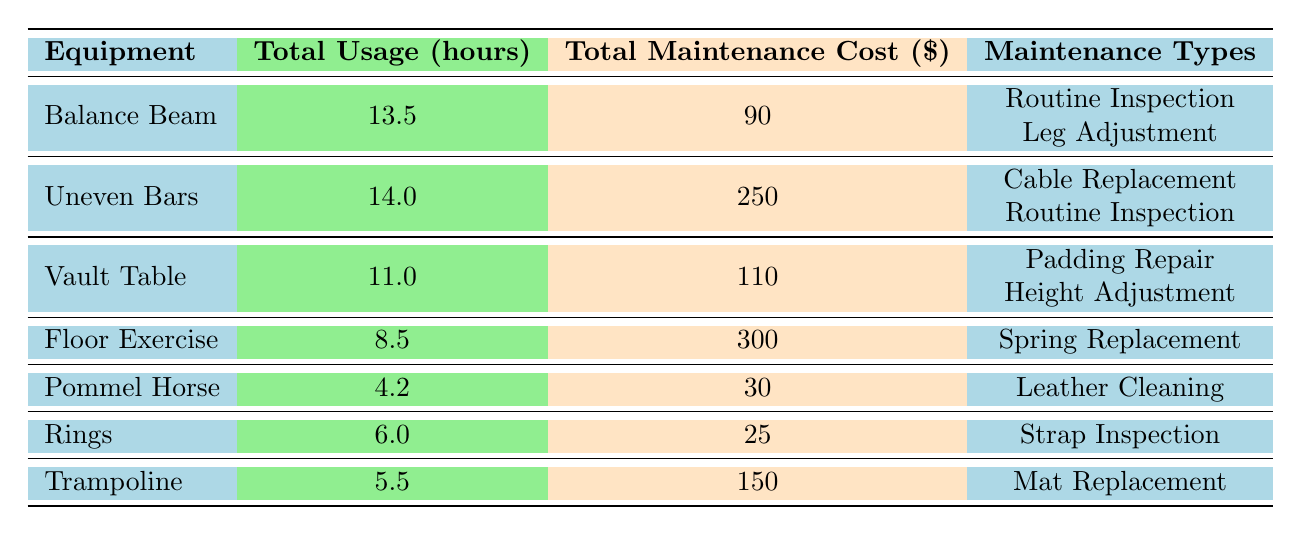What is the total usage hours for the Balance Beam? The total usage hours for the Balance Beam are presented directly in the table under the "Total Usage (hours)" column. The value listed for the Balance Beam is 13.5 hours.
Answer: 13.5 What is the total maintenance cost for the Vault Table? The total maintenance cost for the Vault Table can be found in the "Total Maintenance Cost ($)" column. The value given for the Vault Table is 110 dollars.
Answer: 110 Is the Floor Exercise associated with any routine inspections? Reviewing the "Maintenance Types" for the Floor Exercise reveals that the only maintenance type listed is "Spring Replacement." Therefore, there are no routine inspections associated with this equipment.
Answer: No Which equipment has the highest total maintenance cost? The total maintenance costs are compared across all equipment in the "Total Maintenance Cost ($)" column. The highest value is 300 dollars for the Floor Exercise.
Answer: Floor Exercise How many types of maintenance were performed for the Uneven Bars? Looking at the "Maintenance Types" column for the Uneven Bars, there are 2 types listed: "Cable Replacement" and "Routine Inspection." Hence, the total types of maintenance is 2.
Answer: 2 What is the average total maintenance cost for all equipment? To find the average maintenance cost, we sum all the costs: 90 + 250 + 110 + 300 + 30 + 25 + 150 = 955. Then, dividing this sum by the number of equipment types (7), gives us an average of 955 / 7 = 136.43.
Answer: 136.43 Was any maintenance performed by Emily Chen? By reviewing the "Performed By" column, we can see that Emily Chen performed maintenance for two types of equipment: the Balance Beam and the Vault Table. Therefore, the answer is yes.
Answer: Yes Which equipment had the least usage hours? Examining the "Total Usage (hours)" column, the Pommel Horse has the least usage hours listed at 4.2 hours. Therefore, it is the equipment with the least usage hours.
Answer: Pommel Horse What is the difference in total usage hours between the Uneven Bars and the Trampoline? The total usage hours for the Uneven Bars is 14.0, while for the Trampoline, it is 5.5. Subtracting these values gives us 14.0 - 5.5 = 8.5 hours difference.
Answer: 8.5 